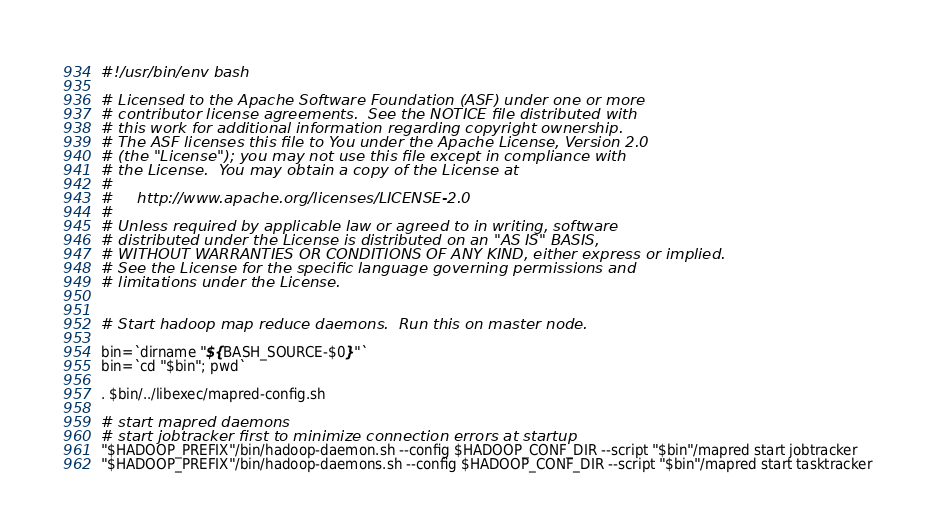Convert code to text. <code><loc_0><loc_0><loc_500><loc_500><_Bash_>#!/usr/bin/env bash

# Licensed to the Apache Software Foundation (ASF) under one or more
# contributor license agreements.  See the NOTICE file distributed with
# this work for additional information regarding copyright ownership.
# The ASF licenses this file to You under the Apache License, Version 2.0
# (the "License"); you may not use this file except in compliance with
# the License.  You may obtain a copy of the License at
#
#     http://www.apache.org/licenses/LICENSE-2.0
#
# Unless required by applicable law or agreed to in writing, software
# distributed under the License is distributed on an "AS IS" BASIS,
# WITHOUT WARRANTIES OR CONDITIONS OF ANY KIND, either express or implied.
# See the License for the specific language governing permissions and
# limitations under the License.


# Start hadoop map reduce daemons.  Run this on master node.

bin=`dirname "${BASH_SOURCE-$0}"`
bin=`cd "$bin"; pwd`

. $bin/../libexec/mapred-config.sh

# start mapred daemons
# start jobtracker first to minimize connection errors at startup
"$HADOOP_PREFIX"/bin/hadoop-daemon.sh --config $HADOOP_CONF_DIR --script "$bin"/mapred start jobtracker
"$HADOOP_PREFIX"/bin/hadoop-daemons.sh --config $HADOOP_CONF_DIR --script "$bin"/mapred start tasktracker
</code> 